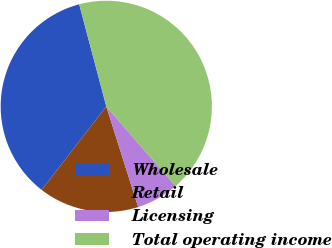Convert chart. <chart><loc_0><loc_0><loc_500><loc_500><pie_chart><fcel>Wholesale<fcel>Retail<fcel>Licensing<fcel>Total operating income<nl><fcel>35.39%<fcel>15.37%<fcel>6.49%<fcel>42.75%<nl></chart> 